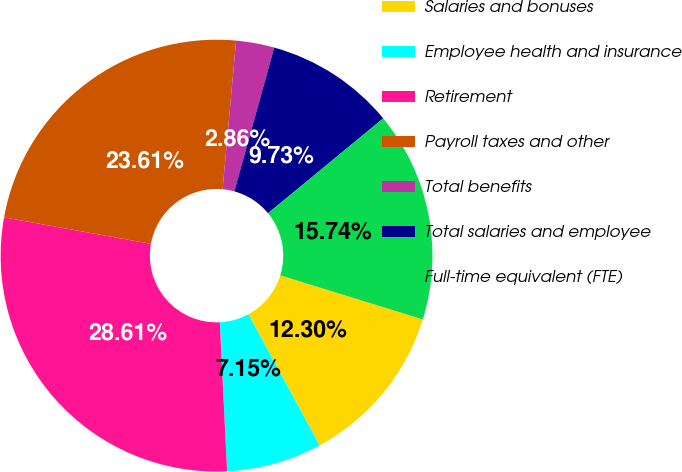Convert chart to OTSL. <chart><loc_0><loc_0><loc_500><loc_500><pie_chart><fcel>Salaries and bonuses<fcel>Employee health and insurance<fcel>Retirement<fcel>Payroll taxes and other<fcel>Total benefits<fcel>Total salaries and employee<fcel>Full-time equivalent (FTE)<nl><fcel>12.3%<fcel>7.15%<fcel>28.61%<fcel>23.61%<fcel>2.86%<fcel>9.73%<fcel>15.74%<nl></chart> 